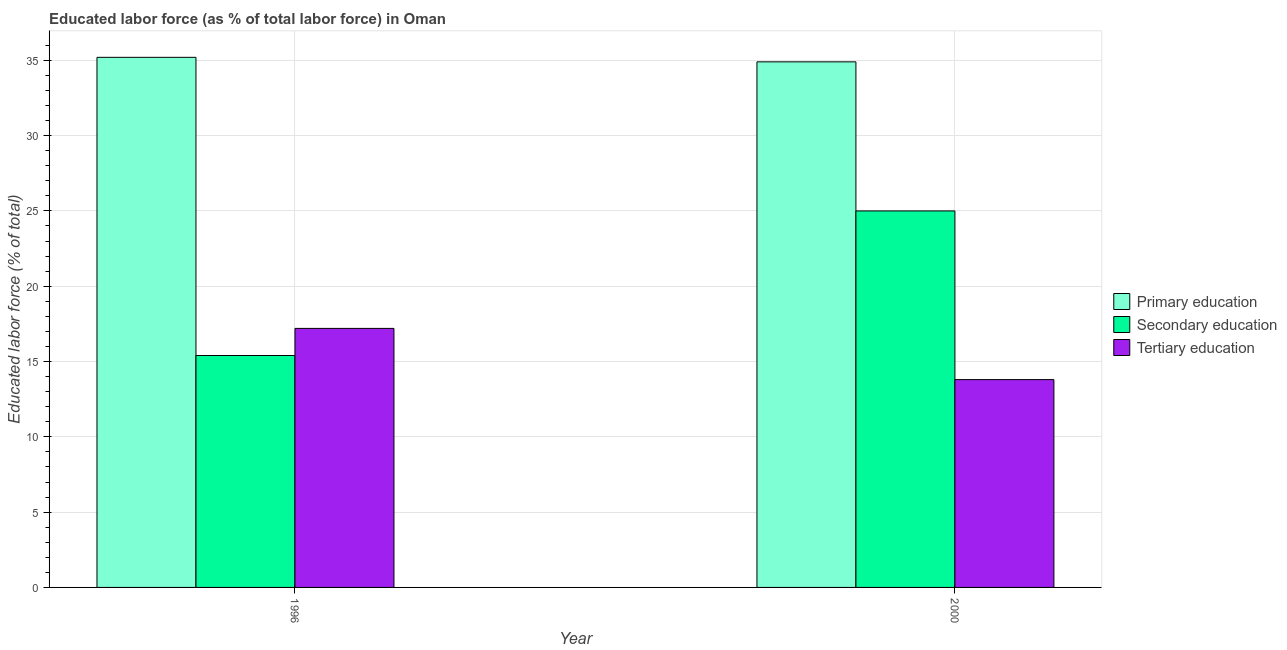Are the number of bars per tick equal to the number of legend labels?
Give a very brief answer. Yes. What is the label of the 1st group of bars from the left?
Give a very brief answer. 1996. In how many cases, is the number of bars for a given year not equal to the number of legend labels?
Your answer should be very brief. 0. What is the percentage of labor force who received primary education in 2000?
Your response must be concise. 34.9. Across all years, what is the maximum percentage of labor force who received tertiary education?
Ensure brevity in your answer.  17.2. Across all years, what is the minimum percentage of labor force who received tertiary education?
Your response must be concise. 13.8. What is the total percentage of labor force who received tertiary education in the graph?
Provide a succinct answer. 31. What is the difference between the percentage of labor force who received tertiary education in 1996 and that in 2000?
Your answer should be compact. 3.4. What is the difference between the percentage of labor force who received tertiary education in 1996 and the percentage of labor force who received primary education in 2000?
Make the answer very short. 3.4. What is the average percentage of labor force who received tertiary education per year?
Your answer should be compact. 15.5. In how many years, is the percentage of labor force who received primary education greater than 23 %?
Ensure brevity in your answer.  2. What is the ratio of the percentage of labor force who received secondary education in 1996 to that in 2000?
Your response must be concise. 0.62. What does the 1st bar from the left in 1996 represents?
Provide a short and direct response. Primary education. What does the 3rd bar from the right in 2000 represents?
Ensure brevity in your answer.  Primary education. Is it the case that in every year, the sum of the percentage of labor force who received primary education and percentage of labor force who received secondary education is greater than the percentage of labor force who received tertiary education?
Your answer should be very brief. Yes. How many bars are there?
Offer a terse response. 6. How many years are there in the graph?
Provide a succinct answer. 2. Are the values on the major ticks of Y-axis written in scientific E-notation?
Give a very brief answer. No. Does the graph contain any zero values?
Ensure brevity in your answer.  No. How many legend labels are there?
Provide a succinct answer. 3. How are the legend labels stacked?
Provide a succinct answer. Vertical. What is the title of the graph?
Provide a short and direct response. Educated labor force (as % of total labor force) in Oman. Does "Taxes on international trade" appear as one of the legend labels in the graph?
Make the answer very short. No. What is the label or title of the X-axis?
Your answer should be very brief. Year. What is the label or title of the Y-axis?
Provide a short and direct response. Educated labor force (% of total). What is the Educated labor force (% of total) of Primary education in 1996?
Offer a terse response. 35.2. What is the Educated labor force (% of total) of Secondary education in 1996?
Your answer should be compact. 15.4. What is the Educated labor force (% of total) of Tertiary education in 1996?
Your response must be concise. 17.2. What is the Educated labor force (% of total) of Primary education in 2000?
Keep it short and to the point. 34.9. What is the Educated labor force (% of total) in Tertiary education in 2000?
Your response must be concise. 13.8. Across all years, what is the maximum Educated labor force (% of total) in Primary education?
Your answer should be compact. 35.2. Across all years, what is the maximum Educated labor force (% of total) of Secondary education?
Your answer should be very brief. 25. Across all years, what is the maximum Educated labor force (% of total) in Tertiary education?
Ensure brevity in your answer.  17.2. Across all years, what is the minimum Educated labor force (% of total) of Primary education?
Offer a very short reply. 34.9. Across all years, what is the minimum Educated labor force (% of total) in Secondary education?
Offer a terse response. 15.4. Across all years, what is the minimum Educated labor force (% of total) in Tertiary education?
Keep it short and to the point. 13.8. What is the total Educated labor force (% of total) of Primary education in the graph?
Make the answer very short. 70.1. What is the total Educated labor force (% of total) in Secondary education in the graph?
Provide a succinct answer. 40.4. What is the difference between the Educated labor force (% of total) in Primary education in 1996 and that in 2000?
Keep it short and to the point. 0.3. What is the difference between the Educated labor force (% of total) in Tertiary education in 1996 and that in 2000?
Your response must be concise. 3.4. What is the difference between the Educated labor force (% of total) in Primary education in 1996 and the Educated labor force (% of total) in Secondary education in 2000?
Ensure brevity in your answer.  10.2. What is the difference between the Educated labor force (% of total) of Primary education in 1996 and the Educated labor force (% of total) of Tertiary education in 2000?
Offer a very short reply. 21.4. What is the average Educated labor force (% of total) in Primary education per year?
Ensure brevity in your answer.  35.05. What is the average Educated labor force (% of total) of Secondary education per year?
Provide a short and direct response. 20.2. In the year 1996, what is the difference between the Educated labor force (% of total) of Primary education and Educated labor force (% of total) of Secondary education?
Make the answer very short. 19.8. In the year 1996, what is the difference between the Educated labor force (% of total) in Primary education and Educated labor force (% of total) in Tertiary education?
Give a very brief answer. 18. In the year 2000, what is the difference between the Educated labor force (% of total) of Primary education and Educated labor force (% of total) of Secondary education?
Your answer should be compact. 9.9. In the year 2000, what is the difference between the Educated labor force (% of total) in Primary education and Educated labor force (% of total) in Tertiary education?
Offer a terse response. 21.1. In the year 2000, what is the difference between the Educated labor force (% of total) of Secondary education and Educated labor force (% of total) of Tertiary education?
Give a very brief answer. 11.2. What is the ratio of the Educated labor force (% of total) in Primary education in 1996 to that in 2000?
Your answer should be compact. 1.01. What is the ratio of the Educated labor force (% of total) of Secondary education in 1996 to that in 2000?
Your response must be concise. 0.62. What is the ratio of the Educated labor force (% of total) of Tertiary education in 1996 to that in 2000?
Your answer should be compact. 1.25. What is the difference between the highest and the lowest Educated labor force (% of total) in Secondary education?
Ensure brevity in your answer.  9.6. What is the difference between the highest and the lowest Educated labor force (% of total) in Tertiary education?
Your answer should be very brief. 3.4. 